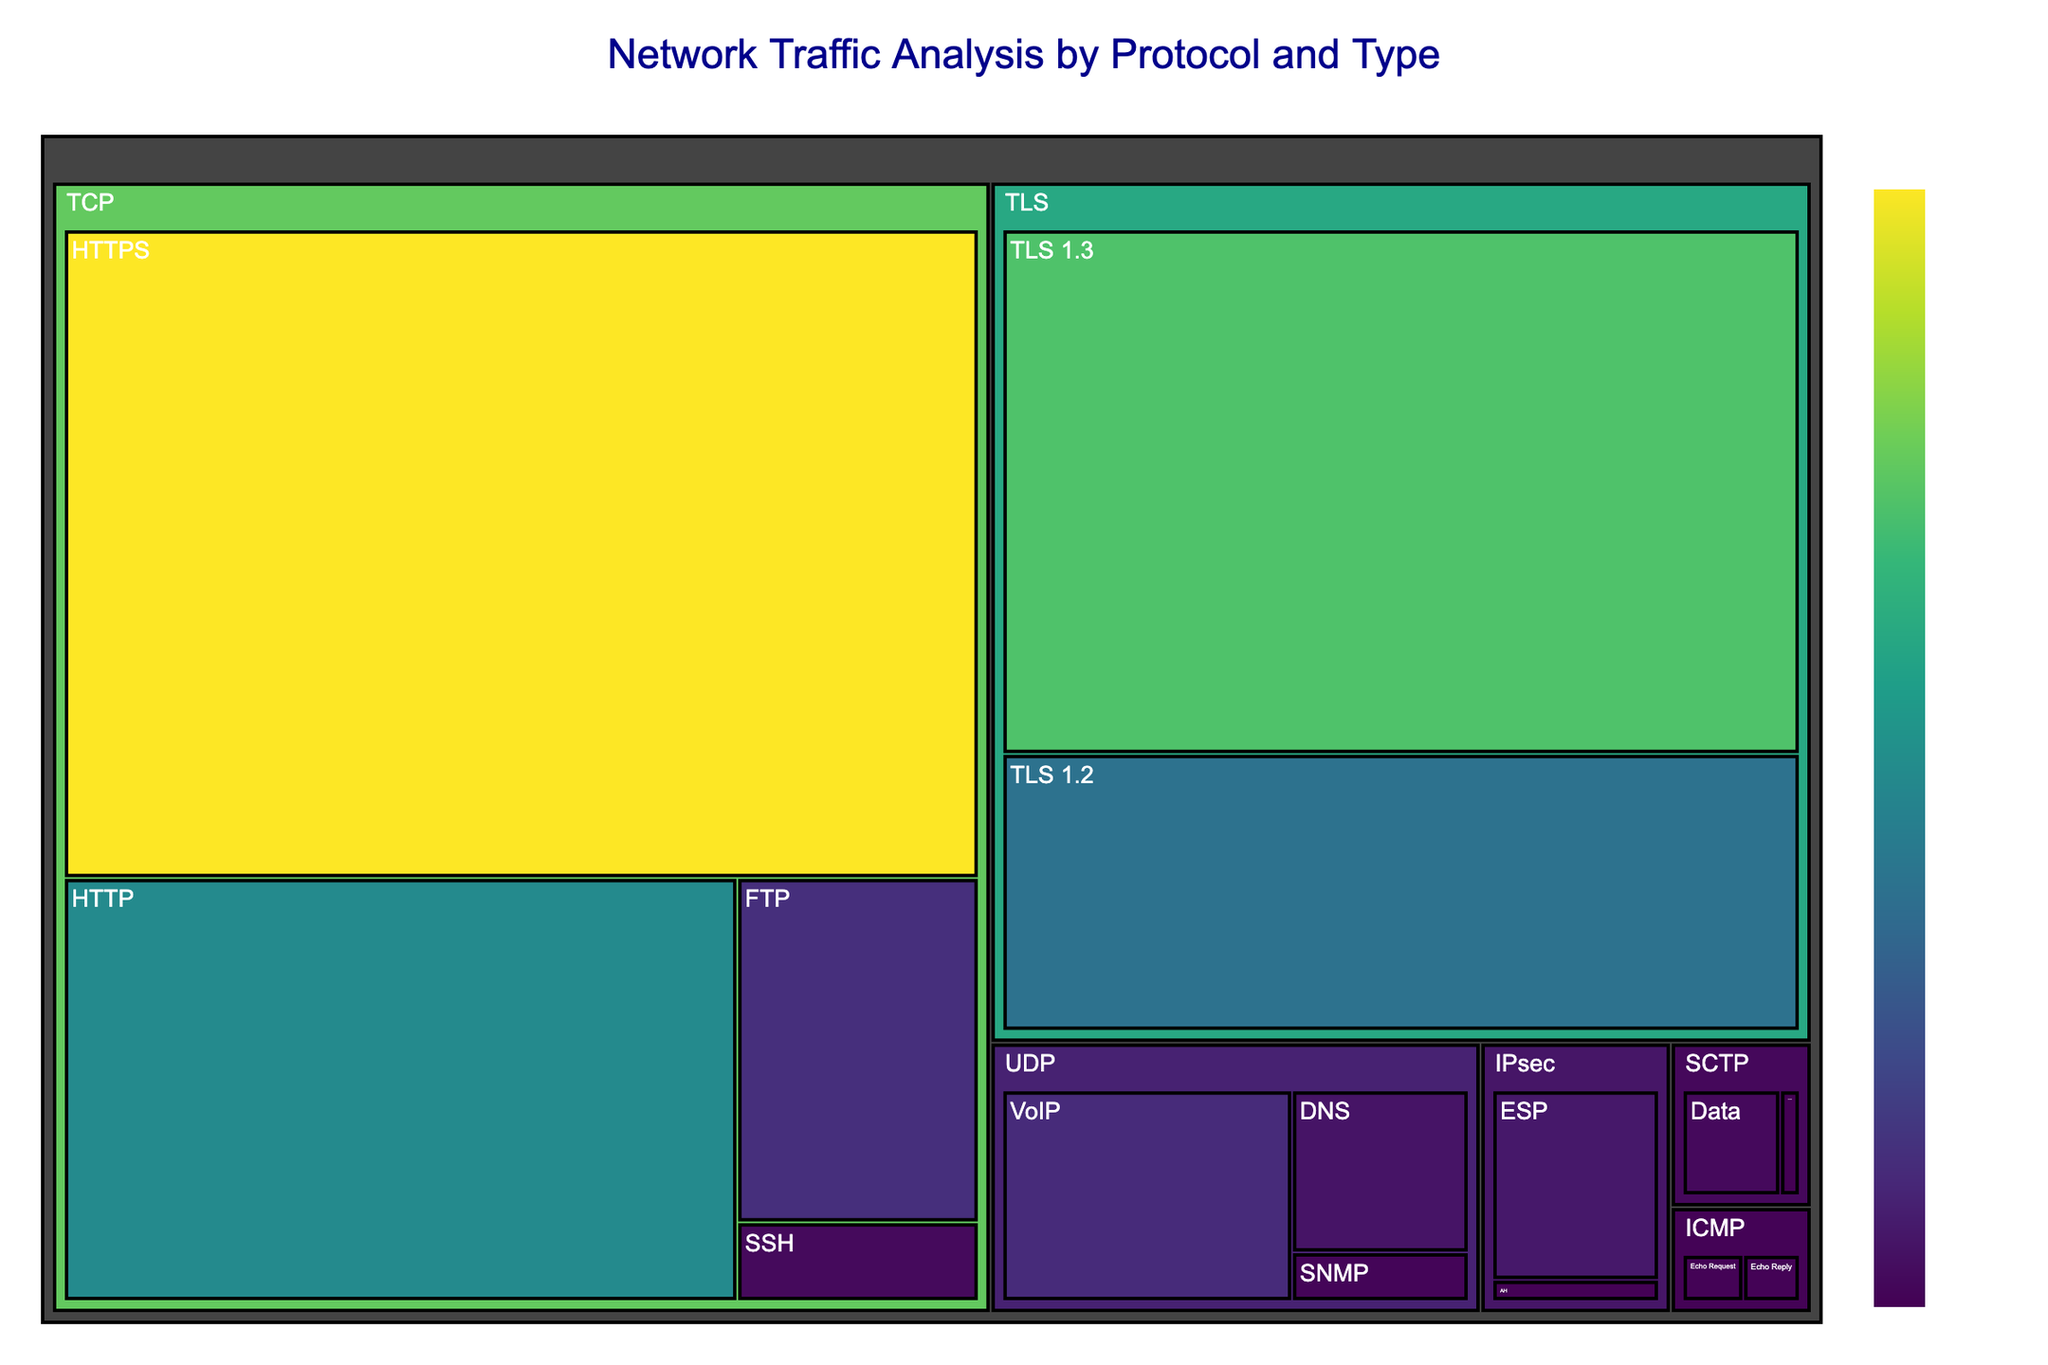What is the title of the treemap? The title of the treemap is typically displayed in the upper part of the figure. It provides an overview of what the figure represents.
Answer: Network Traffic Analysis by Protocol and Type Which protocol and type combination has the highest data volume? To find this, locate the largest block in the treemap, as the size represents the data volume in GB.
Answer: TCP - HTTPS What is the total data volume for all UDP protocol types? Find and sum the volumes for all types under the UDP protocol: DNS (150 GB), SNMP (45 GB), and VoIP (320 GB). So, \(150 + 45 + 320 = 515\) GB.
Answer: 515 GB How does the data volume of TLS 1.3 compare with TLS 1.2? Compare the sizes of the two blocks for TLS 1.3 and TLS 1.2. TLS 1.3 has 1800 GB, and TLS 1.2 has 950 GB.
Answer: TLS 1.3 has a larger volume Which protocol has the smallest data volume, and how much is it? Identify the smallest block in the treemap and check its corresponding protocol type. The smallest block is SCTP - Control with 15 GB.
Answer: SCTP - Control with 15 GB Is the data volume for HTTP traffic larger than that for the entire IPsec traffic? Compare the volume of the HTTP block (1200 GB) with the sum of all IPsec blocks (ESP 180 GB + AH 20 GB = 200 GB).
Answer: Yes, HTTP traffic is larger What is the combined data volume for all TCP types excluding HTTPS? Sum the data volumes for TCP protocol types except for HTTPS: HTTP (1200 GB), FTP (350 GB), and SSH (80 GB). So \(1200 + 350 + 80 = 1630\) GB.
Answer: 1630 GB Which protocol type under UDP has the lowest volume and how much is it? Look at the blocks under UDP and find the smallest one. SNMP (45 GB) is the smallest type under UDP.
Answer: SNMP with 45 GB What is the average data volume across all ICMP types? Sum the volumes of all ICMP protocol types (Echo Request 30 GB + Echo Reply 28 GB = 58 GB) and divide by the number of types (2). So, \(58 / 2 = 29\) GB.
Answer: 29 GB Which protocol has more variance in data volume between its types, TCP or TLS? TCP types vary from 80 GB (SSH) to 2500 GB (HTTPS). TLS types vary from 950 GB (TLS 1.2) to 1800 GB (TLS 1.3). The variance is higher in TCP.
Answer: TCP 